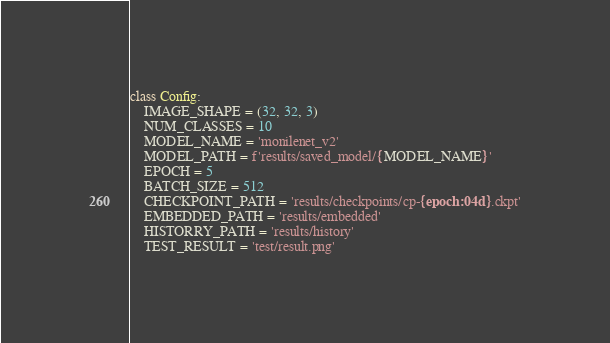<code> <loc_0><loc_0><loc_500><loc_500><_Python_>class Config:
    IMAGE_SHAPE = (32, 32, 3)
    NUM_CLASSES = 10
    MODEL_NAME = 'monilenet_v2'
    MODEL_PATH = f'results/saved_model/{MODEL_NAME}'
    EPOCH = 5
    BATCH_SIZE = 512
    CHECKPOINT_PATH = 'results/checkpoints/cp-{epoch:04d}.ckpt'
    EMBEDDED_PATH = 'results/embedded'
    HISTORRY_PATH = 'results/history'
    TEST_RESULT = 'test/result.png'
</code> 